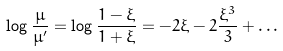Convert formula to latex. <formula><loc_0><loc_0><loc_500><loc_500>\log \frac { \mu } { \mu ^ { \prime } } = \log \frac { 1 - \xi } { 1 + \xi } = - 2 \xi - 2 \frac { \xi ^ { 3 } } { 3 } + \dots</formula> 